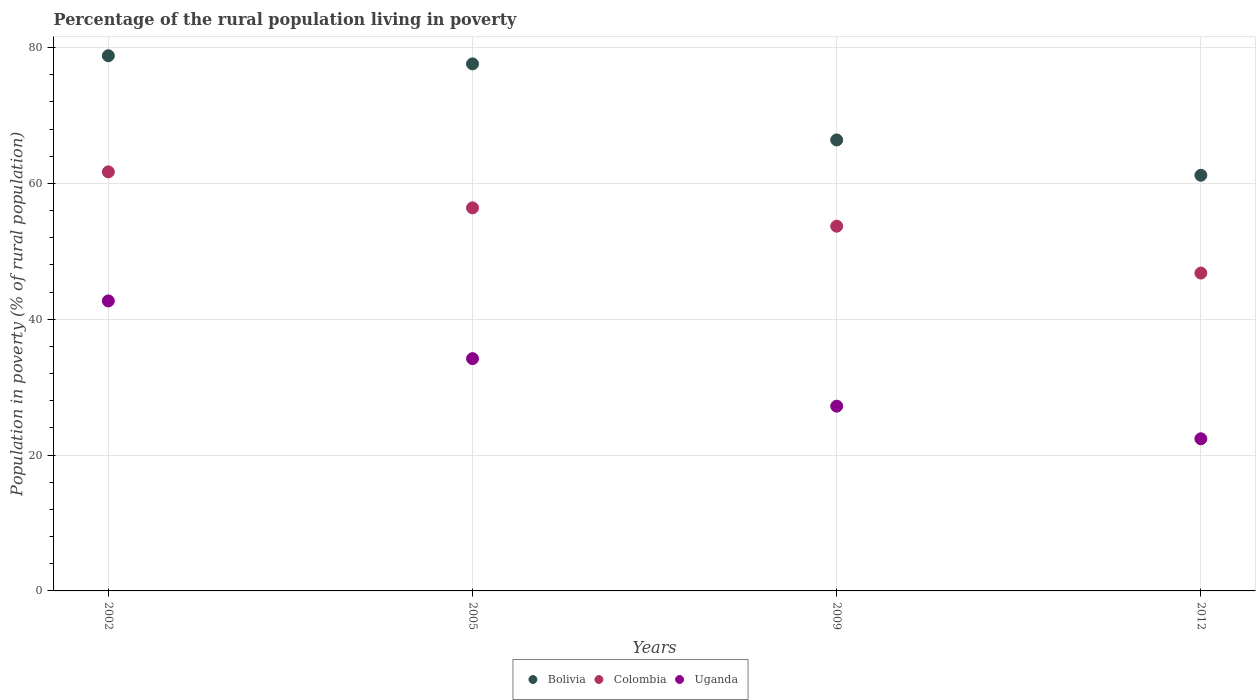How many different coloured dotlines are there?
Keep it short and to the point. 3. Is the number of dotlines equal to the number of legend labels?
Provide a succinct answer. Yes. What is the percentage of the rural population living in poverty in Uganda in 2012?
Offer a terse response. 22.4. Across all years, what is the maximum percentage of the rural population living in poverty in Colombia?
Offer a terse response. 61.7. Across all years, what is the minimum percentage of the rural population living in poverty in Uganda?
Make the answer very short. 22.4. In which year was the percentage of the rural population living in poverty in Bolivia maximum?
Your answer should be compact. 2002. What is the total percentage of the rural population living in poverty in Uganda in the graph?
Offer a terse response. 126.5. What is the difference between the percentage of the rural population living in poverty in Bolivia in 2005 and that in 2012?
Give a very brief answer. 16.4. What is the difference between the percentage of the rural population living in poverty in Colombia in 2005 and the percentage of the rural population living in poverty in Bolivia in 2012?
Give a very brief answer. -4.8. What is the average percentage of the rural population living in poverty in Colombia per year?
Provide a short and direct response. 54.65. In how many years, is the percentage of the rural population living in poverty in Colombia greater than 32 %?
Ensure brevity in your answer.  4. What is the ratio of the percentage of the rural population living in poverty in Bolivia in 2002 to that in 2005?
Your answer should be compact. 1.02. Is the difference between the percentage of the rural population living in poverty in Uganda in 2002 and 2012 greater than the difference between the percentage of the rural population living in poverty in Colombia in 2002 and 2012?
Keep it short and to the point. Yes. What is the difference between the highest and the lowest percentage of the rural population living in poverty in Bolivia?
Give a very brief answer. 17.6. In how many years, is the percentage of the rural population living in poverty in Uganda greater than the average percentage of the rural population living in poverty in Uganda taken over all years?
Your answer should be compact. 2. Is it the case that in every year, the sum of the percentage of the rural population living in poverty in Colombia and percentage of the rural population living in poverty in Bolivia  is greater than the percentage of the rural population living in poverty in Uganda?
Your answer should be compact. Yes. Does the percentage of the rural population living in poverty in Colombia monotonically increase over the years?
Ensure brevity in your answer.  No. Is the percentage of the rural population living in poverty in Uganda strictly greater than the percentage of the rural population living in poverty in Bolivia over the years?
Your answer should be compact. No. Is the percentage of the rural population living in poverty in Uganda strictly less than the percentage of the rural population living in poverty in Bolivia over the years?
Your answer should be compact. Yes. How many dotlines are there?
Provide a succinct answer. 3. Are the values on the major ticks of Y-axis written in scientific E-notation?
Provide a short and direct response. No. Does the graph contain grids?
Provide a short and direct response. Yes. Where does the legend appear in the graph?
Offer a terse response. Bottom center. How are the legend labels stacked?
Your answer should be compact. Horizontal. What is the title of the graph?
Make the answer very short. Percentage of the rural population living in poverty. Does "Turkey" appear as one of the legend labels in the graph?
Ensure brevity in your answer.  No. What is the label or title of the Y-axis?
Give a very brief answer. Population in poverty (% of rural population). What is the Population in poverty (% of rural population) of Bolivia in 2002?
Offer a very short reply. 78.8. What is the Population in poverty (% of rural population) in Colombia in 2002?
Make the answer very short. 61.7. What is the Population in poverty (% of rural population) in Uganda in 2002?
Offer a very short reply. 42.7. What is the Population in poverty (% of rural population) in Bolivia in 2005?
Offer a terse response. 77.6. What is the Population in poverty (% of rural population) in Colombia in 2005?
Make the answer very short. 56.4. What is the Population in poverty (% of rural population) of Uganda in 2005?
Offer a terse response. 34.2. What is the Population in poverty (% of rural population) in Bolivia in 2009?
Make the answer very short. 66.4. What is the Population in poverty (% of rural population) in Colombia in 2009?
Your answer should be compact. 53.7. What is the Population in poverty (% of rural population) in Uganda in 2009?
Your answer should be compact. 27.2. What is the Population in poverty (% of rural population) in Bolivia in 2012?
Provide a succinct answer. 61.2. What is the Population in poverty (% of rural population) of Colombia in 2012?
Offer a terse response. 46.8. What is the Population in poverty (% of rural population) in Uganda in 2012?
Ensure brevity in your answer.  22.4. Across all years, what is the maximum Population in poverty (% of rural population) of Bolivia?
Provide a succinct answer. 78.8. Across all years, what is the maximum Population in poverty (% of rural population) of Colombia?
Provide a succinct answer. 61.7. Across all years, what is the maximum Population in poverty (% of rural population) in Uganda?
Give a very brief answer. 42.7. Across all years, what is the minimum Population in poverty (% of rural population) of Bolivia?
Provide a succinct answer. 61.2. Across all years, what is the minimum Population in poverty (% of rural population) in Colombia?
Your answer should be very brief. 46.8. Across all years, what is the minimum Population in poverty (% of rural population) in Uganda?
Offer a terse response. 22.4. What is the total Population in poverty (% of rural population) in Bolivia in the graph?
Provide a short and direct response. 284. What is the total Population in poverty (% of rural population) of Colombia in the graph?
Give a very brief answer. 218.6. What is the total Population in poverty (% of rural population) in Uganda in the graph?
Provide a short and direct response. 126.5. What is the difference between the Population in poverty (% of rural population) of Colombia in 2002 and that in 2005?
Make the answer very short. 5.3. What is the difference between the Population in poverty (% of rural population) of Uganda in 2002 and that in 2005?
Ensure brevity in your answer.  8.5. What is the difference between the Population in poverty (% of rural population) in Uganda in 2002 and that in 2009?
Give a very brief answer. 15.5. What is the difference between the Population in poverty (% of rural population) of Colombia in 2002 and that in 2012?
Ensure brevity in your answer.  14.9. What is the difference between the Population in poverty (% of rural population) in Uganda in 2002 and that in 2012?
Give a very brief answer. 20.3. What is the difference between the Population in poverty (% of rural population) of Colombia in 2005 and that in 2012?
Your response must be concise. 9.6. What is the difference between the Population in poverty (% of rural population) in Bolivia in 2009 and that in 2012?
Provide a short and direct response. 5.2. What is the difference between the Population in poverty (% of rural population) of Bolivia in 2002 and the Population in poverty (% of rural population) of Colombia in 2005?
Your answer should be very brief. 22.4. What is the difference between the Population in poverty (% of rural population) of Bolivia in 2002 and the Population in poverty (% of rural population) of Uganda in 2005?
Provide a short and direct response. 44.6. What is the difference between the Population in poverty (% of rural population) of Colombia in 2002 and the Population in poverty (% of rural population) of Uganda in 2005?
Provide a succinct answer. 27.5. What is the difference between the Population in poverty (% of rural population) in Bolivia in 2002 and the Population in poverty (% of rural population) in Colombia in 2009?
Your answer should be very brief. 25.1. What is the difference between the Population in poverty (% of rural population) in Bolivia in 2002 and the Population in poverty (% of rural population) in Uganda in 2009?
Make the answer very short. 51.6. What is the difference between the Population in poverty (% of rural population) of Colombia in 2002 and the Population in poverty (% of rural population) of Uganda in 2009?
Ensure brevity in your answer.  34.5. What is the difference between the Population in poverty (% of rural population) in Bolivia in 2002 and the Population in poverty (% of rural population) in Uganda in 2012?
Keep it short and to the point. 56.4. What is the difference between the Population in poverty (% of rural population) in Colombia in 2002 and the Population in poverty (% of rural population) in Uganda in 2012?
Ensure brevity in your answer.  39.3. What is the difference between the Population in poverty (% of rural population) in Bolivia in 2005 and the Population in poverty (% of rural population) in Colombia in 2009?
Your answer should be very brief. 23.9. What is the difference between the Population in poverty (% of rural population) in Bolivia in 2005 and the Population in poverty (% of rural population) in Uganda in 2009?
Make the answer very short. 50.4. What is the difference between the Population in poverty (% of rural population) in Colombia in 2005 and the Population in poverty (% of rural population) in Uganda in 2009?
Your answer should be compact. 29.2. What is the difference between the Population in poverty (% of rural population) of Bolivia in 2005 and the Population in poverty (% of rural population) of Colombia in 2012?
Give a very brief answer. 30.8. What is the difference between the Population in poverty (% of rural population) in Bolivia in 2005 and the Population in poverty (% of rural population) in Uganda in 2012?
Your answer should be very brief. 55.2. What is the difference between the Population in poverty (% of rural population) in Colombia in 2005 and the Population in poverty (% of rural population) in Uganda in 2012?
Ensure brevity in your answer.  34. What is the difference between the Population in poverty (% of rural population) of Bolivia in 2009 and the Population in poverty (% of rural population) of Colombia in 2012?
Your answer should be compact. 19.6. What is the difference between the Population in poverty (% of rural population) of Colombia in 2009 and the Population in poverty (% of rural population) of Uganda in 2012?
Offer a terse response. 31.3. What is the average Population in poverty (% of rural population) in Colombia per year?
Provide a short and direct response. 54.65. What is the average Population in poverty (% of rural population) of Uganda per year?
Your answer should be very brief. 31.62. In the year 2002, what is the difference between the Population in poverty (% of rural population) in Bolivia and Population in poverty (% of rural population) in Colombia?
Your answer should be very brief. 17.1. In the year 2002, what is the difference between the Population in poverty (% of rural population) in Bolivia and Population in poverty (% of rural population) in Uganda?
Keep it short and to the point. 36.1. In the year 2005, what is the difference between the Population in poverty (% of rural population) of Bolivia and Population in poverty (% of rural population) of Colombia?
Offer a terse response. 21.2. In the year 2005, what is the difference between the Population in poverty (% of rural population) of Bolivia and Population in poverty (% of rural population) of Uganda?
Keep it short and to the point. 43.4. In the year 2009, what is the difference between the Population in poverty (% of rural population) in Bolivia and Population in poverty (% of rural population) in Uganda?
Make the answer very short. 39.2. In the year 2009, what is the difference between the Population in poverty (% of rural population) in Colombia and Population in poverty (% of rural population) in Uganda?
Ensure brevity in your answer.  26.5. In the year 2012, what is the difference between the Population in poverty (% of rural population) of Bolivia and Population in poverty (% of rural population) of Uganda?
Your answer should be very brief. 38.8. In the year 2012, what is the difference between the Population in poverty (% of rural population) in Colombia and Population in poverty (% of rural population) in Uganda?
Offer a terse response. 24.4. What is the ratio of the Population in poverty (% of rural population) of Bolivia in 2002 to that in 2005?
Your response must be concise. 1.02. What is the ratio of the Population in poverty (% of rural population) in Colombia in 2002 to that in 2005?
Make the answer very short. 1.09. What is the ratio of the Population in poverty (% of rural population) of Uganda in 2002 to that in 2005?
Your answer should be very brief. 1.25. What is the ratio of the Population in poverty (% of rural population) of Bolivia in 2002 to that in 2009?
Your answer should be very brief. 1.19. What is the ratio of the Population in poverty (% of rural population) of Colombia in 2002 to that in 2009?
Keep it short and to the point. 1.15. What is the ratio of the Population in poverty (% of rural population) in Uganda in 2002 to that in 2009?
Provide a succinct answer. 1.57. What is the ratio of the Population in poverty (% of rural population) of Bolivia in 2002 to that in 2012?
Your answer should be compact. 1.29. What is the ratio of the Population in poverty (% of rural population) of Colombia in 2002 to that in 2012?
Your answer should be very brief. 1.32. What is the ratio of the Population in poverty (% of rural population) of Uganda in 2002 to that in 2012?
Your answer should be compact. 1.91. What is the ratio of the Population in poverty (% of rural population) of Bolivia in 2005 to that in 2009?
Keep it short and to the point. 1.17. What is the ratio of the Population in poverty (% of rural population) of Colombia in 2005 to that in 2009?
Offer a terse response. 1.05. What is the ratio of the Population in poverty (% of rural population) in Uganda in 2005 to that in 2009?
Your response must be concise. 1.26. What is the ratio of the Population in poverty (% of rural population) of Bolivia in 2005 to that in 2012?
Your answer should be compact. 1.27. What is the ratio of the Population in poverty (% of rural population) of Colombia in 2005 to that in 2012?
Give a very brief answer. 1.21. What is the ratio of the Population in poverty (% of rural population) in Uganda in 2005 to that in 2012?
Ensure brevity in your answer.  1.53. What is the ratio of the Population in poverty (% of rural population) of Bolivia in 2009 to that in 2012?
Provide a succinct answer. 1.08. What is the ratio of the Population in poverty (% of rural population) of Colombia in 2009 to that in 2012?
Make the answer very short. 1.15. What is the ratio of the Population in poverty (% of rural population) of Uganda in 2009 to that in 2012?
Your answer should be compact. 1.21. What is the difference between the highest and the second highest Population in poverty (% of rural population) in Bolivia?
Give a very brief answer. 1.2. What is the difference between the highest and the second highest Population in poverty (% of rural population) in Colombia?
Offer a terse response. 5.3. What is the difference between the highest and the second highest Population in poverty (% of rural population) of Uganda?
Offer a very short reply. 8.5. What is the difference between the highest and the lowest Population in poverty (% of rural population) in Bolivia?
Provide a short and direct response. 17.6. What is the difference between the highest and the lowest Population in poverty (% of rural population) of Colombia?
Ensure brevity in your answer.  14.9. What is the difference between the highest and the lowest Population in poverty (% of rural population) in Uganda?
Your answer should be compact. 20.3. 